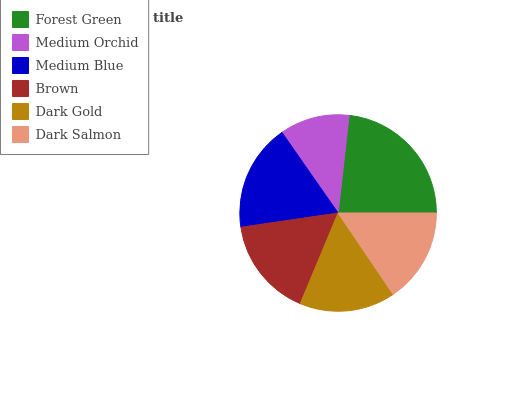Is Medium Orchid the minimum?
Answer yes or no. Yes. Is Forest Green the maximum?
Answer yes or no. Yes. Is Medium Blue the minimum?
Answer yes or no. No. Is Medium Blue the maximum?
Answer yes or no. No. Is Medium Blue greater than Medium Orchid?
Answer yes or no. Yes. Is Medium Orchid less than Medium Blue?
Answer yes or no. Yes. Is Medium Orchid greater than Medium Blue?
Answer yes or no. No. Is Medium Blue less than Medium Orchid?
Answer yes or no. No. Is Brown the high median?
Answer yes or no. Yes. Is Dark Gold the low median?
Answer yes or no. Yes. Is Forest Green the high median?
Answer yes or no. No. Is Medium Orchid the low median?
Answer yes or no. No. 